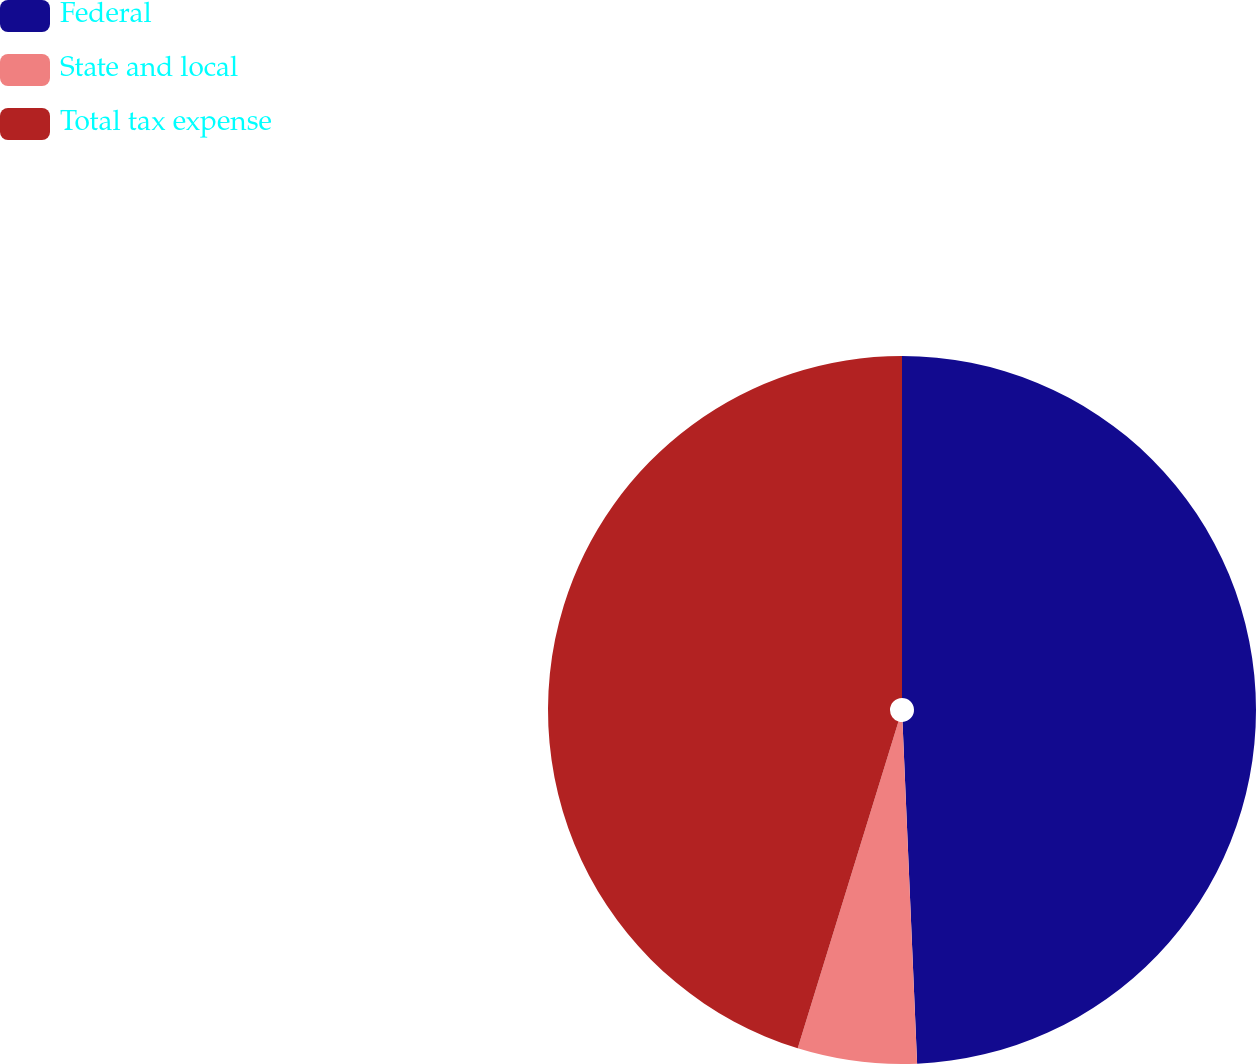Convert chart. <chart><loc_0><loc_0><loc_500><loc_500><pie_chart><fcel>Federal<fcel>State and local<fcel>Total tax expense<nl><fcel>49.32%<fcel>5.44%<fcel>45.24%<nl></chart> 